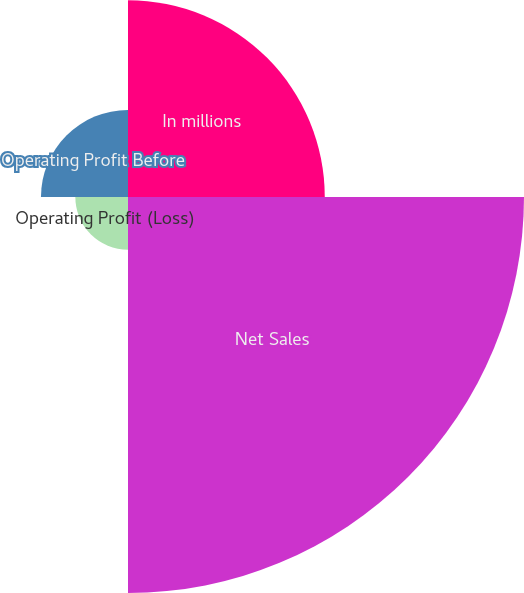Convert chart. <chart><loc_0><loc_0><loc_500><loc_500><pie_chart><fcel>In millions<fcel>Net Sales<fcel>Operating Profit (Loss)<fcel>Operating Profit Before<nl><fcel>26.86%<fcel>54.06%<fcel>7.19%<fcel>11.88%<nl></chart> 